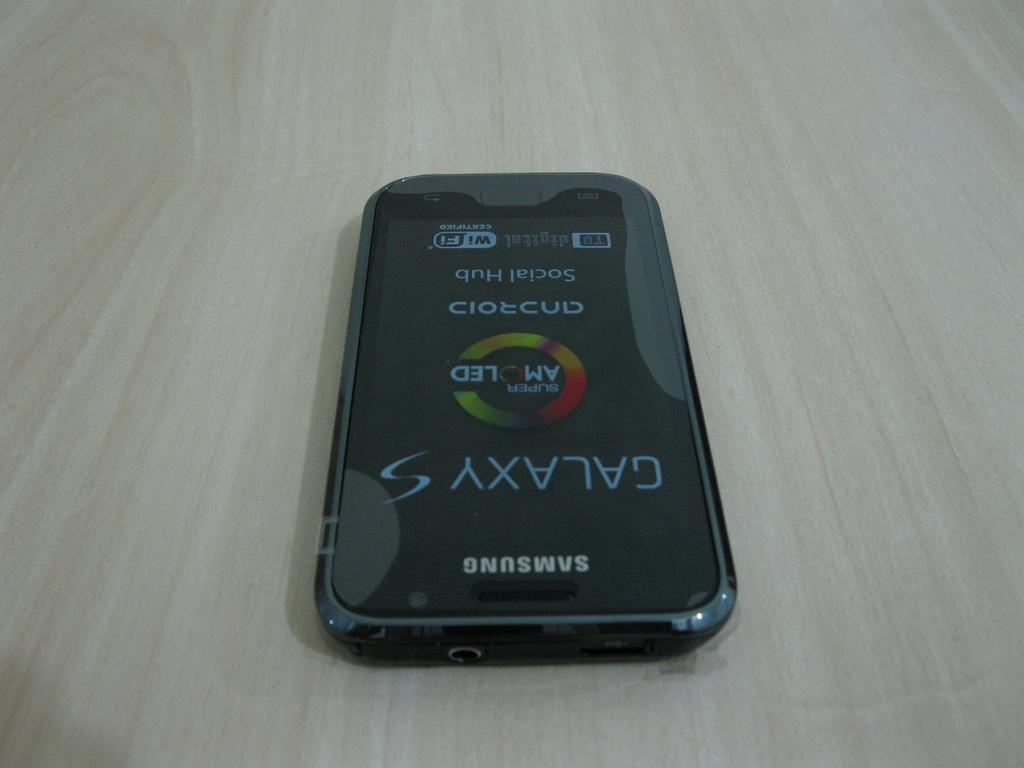<image>
Summarize the visual content of the image. A Samsung Galaxy S phone displays Social Hub and Super Amoled on the screen. 